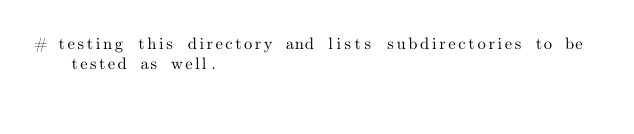<code> <loc_0><loc_0><loc_500><loc_500><_CMake_># testing this directory and lists subdirectories to be tested as well.
</code> 